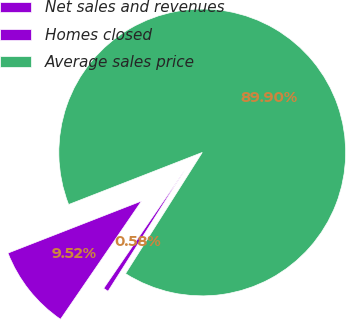<chart> <loc_0><loc_0><loc_500><loc_500><pie_chart><fcel>Net sales and revenues<fcel>Homes closed<fcel>Average sales price<nl><fcel>9.52%<fcel>0.58%<fcel>89.9%<nl></chart> 